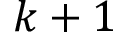<formula> <loc_0><loc_0><loc_500><loc_500>k + 1</formula> 